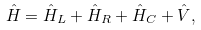<formula> <loc_0><loc_0><loc_500><loc_500>\hat { H } = \hat { H } _ { L } + \hat { H } _ { R } + \hat { H } _ { C } + \hat { V } ,</formula> 